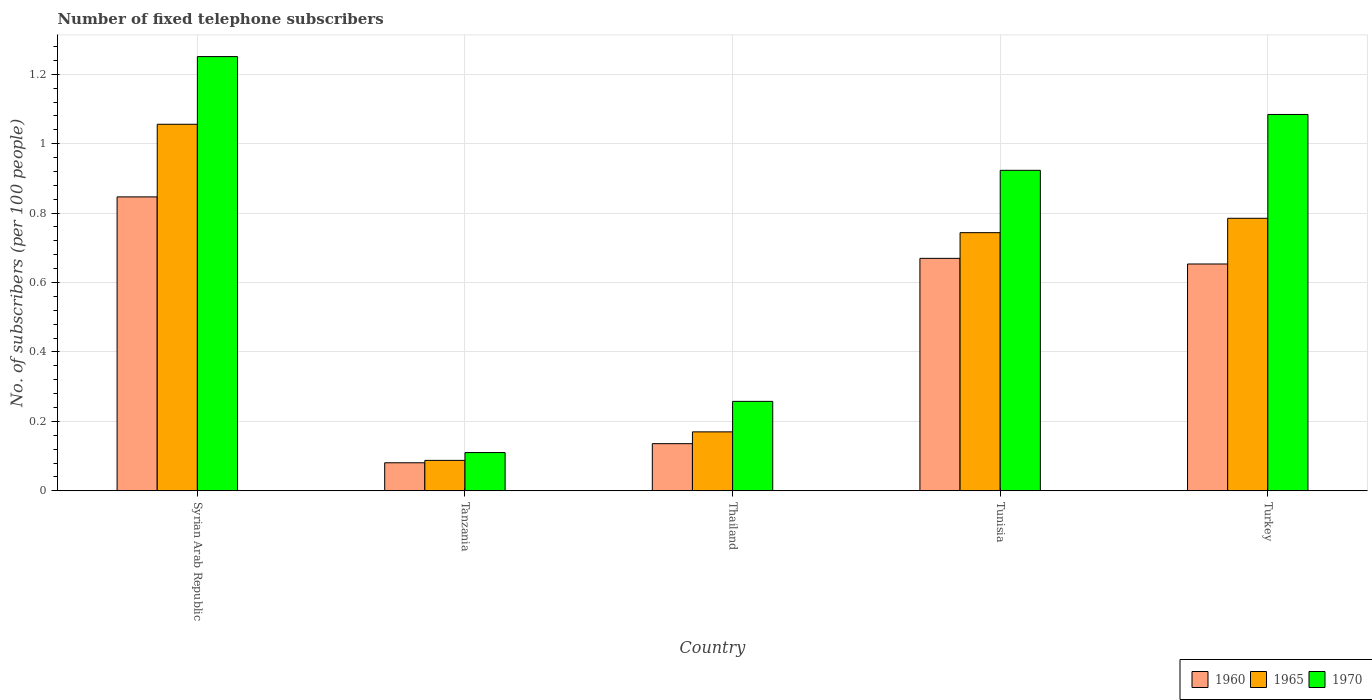How many groups of bars are there?
Your answer should be very brief. 5. Are the number of bars per tick equal to the number of legend labels?
Make the answer very short. Yes. What is the label of the 1st group of bars from the left?
Your response must be concise. Syrian Arab Republic. In how many cases, is the number of bars for a given country not equal to the number of legend labels?
Keep it short and to the point. 0. What is the number of fixed telephone subscribers in 1970 in Turkey?
Ensure brevity in your answer.  1.08. Across all countries, what is the maximum number of fixed telephone subscribers in 1960?
Provide a succinct answer. 0.85. Across all countries, what is the minimum number of fixed telephone subscribers in 1960?
Offer a very short reply. 0.08. In which country was the number of fixed telephone subscribers in 1965 maximum?
Provide a succinct answer. Syrian Arab Republic. In which country was the number of fixed telephone subscribers in 1960 minimum?
Your response must be concise. Tanzania. What is the total number of fixed telephone subscribers in 1965 in the graph?
Offer a very short reply. 2.84. What is the difference between the number of fixed telephone subscribers in 1970 in Syrian Arab Republic and that in Tunisia?
Your answer should be compact. 0.33. What is the difference between the number of fixed telephone subscribers in 1960 in Turkey and the number of fixed telephone subscribers in 1970 in Syrian Arab Republic?
Offer a very short reply. -0.6. What is the average number of fixed telephone subscribers in 1965 per country?
Provide a succinct answer. 0.57. What is the difference between the number of fixed telephone subscribers of/in 1970 and number of fixed telephone subscribers of/in 1960 in Thailand?
Give a very brief answer. 0.12. What is the ratio of the number of fixed telephone subscribers in 1965 in Syrian Arab Republic to that in Tunisia?
Keep it short and to the point. 1.42. Is the number of fixed telephone subscribers in 1960 in Syrian Arab Republic less than that in Thailand?
Offer a terse response. No. What is the difference between the highest and the second highest number of fixed telephone subscribers in 1970?
Offer a terse response. -0.33. What is the difference between the highest and the lowest number of fixed telephone subscribers in 1960?
Your response must be concise. 0.77. Is the sum of the number of fixed telephone subscribers in 1965 in Tanzania and Thailand greater than the maximum number of fixed telephone subscribers in 1970 across all countries?
Keep it short and to the point. No. What does the 1st bar from the left in Thailand represents?
Ensure brevity in your answer.  1960. What does the 2nd bar from the right in Tunisia represents?
Provide a short and direct response. 1965. Is it the case that in every country, the sum of the number of fixed telephone subscribers in 1960 and number of fixed telephone subscribers in 1965 is greater than the number of fixed telephone subscribers in 1970?
Keep it short and to the point. Yes. Are all the bars in the graph horizontal?
Your answer should be very brief. No. How many countries are there in the graph?
Offer a very short reply. 5. What is the difference between two consecutive major ticks on the Y-axis?
Ensure brevity in your answer.  0.2. Are the values on the major ticks of Y-axis written in scientific E-notation?
Ensure brevity in your answer.  No. Does the graph contain grids?
Give a very brief answer. Yes. Where does the legend appear in the graph?
Give a very brief answer. Bottom right. How many legend labels are there?
Your answer should be compact. 3. What is the title of the graph?
Ensure brevity in your answer.  Number of fixed telephone subscribers. What is the label or title of the X-axis?
Offer a very short reply. Country. What is the label or title of the Y-axis?
Your response must be concise. No. of subscribers (per 100 people). What is the No. of subscribers (per 100 people) of 1960 in Syrian Arab Republic?
Ensure brevity in your answer.  0.85. What is the No. of subscribers (per 100 people) of 1965 in Syrian Arab Republic?
Provide a short and direct response. 1.06. What is the No. of subscribers (per 100 people) in 1970 in Syrian Arab Republic?
Your response must be concise. 1.25. What is the No. of subscribers (per 100 people) of 1960 in Tanzania?
Your answer should be very brief. 0.08. What is the No. of subscribers (per 100 people) in 1965 in Tanzania?
Give a very brief answer. 0.09. What is the No. of subscribers (per 100 people) in 1970 in Tanzania?
Ensure brevity in your answer.  0.11. What is the No. of subscribers (per 100 people) of 1960 in Thailand?
Make the answer very short. 0.14. What is the No. of subscribers (per 100 people) of 1965 in Thailand?
Your answer should be compact. 0.17. What is the No. of subscribers (per 100 people) of 1970 in Thailand?
Give a very brief answer. 0.26. What is the No. of subscribers (per 100 people) in 1960 in Tunisia?
Ensure brevity in your answer.  0.67. What is the No. of subscribers (per 100 people) in 1965 in Tunisia?
Ensure brevity in your answer.  0.74. What is the No. of subscribers (per 100 people) of 1970 in Tunisia?
Ensure brevity in your answer.  0.92. What is the No. of subscribers (per 100 people) in 1960 in Turkey?
Provide a succinct answer. 0.65. What is the No. of subscribers (per 100 people) in 1965 in Turkey?
Your answer should be very brief. 0.79. What is the No. of subscribers (per 100 people) of 1970 in Turkey?
Provide a short and direct response. 1.08. Across all countries, what is the maximum No. of subscribers (per 100 people) of 1960?
Ensure brevity in your answer.  0.85. Across all countries, what is the maximum No. of subscribers (per 100 people) in 1965?
Keep it short and to the point. 1.06. Across all countries, what is the maximum No. of subscribers (per 100 people) of 1970?
Ensure brevity in your answer.  1.25. Across all countries, what is the minimum No. of subscribers (per 100 people) in 1960?
Provide a succinct answer. 0.08. Across all countries, what is the minimum No. of subscribers (per 100 people) of 1965?
Offer a terse response. 0.09. Across all countries, what is the minimum No. of subscribers (per 100 people) of 1970?
Offer a very short reply. 0.11. What is the total No. of subscribers (per 100 people) of 1960 in the graph?
Offer a terse response. 2.39. What is the total No. of subscribers (per 100 people) of 1965 in the graph?
Offer a very short reply. 2.84. What is the total No. of subscribers (per 100 people) in 1970 in the graph?
Offer a very short reply. 3.63. What is the difference between the No. of subscribers (per 100 people) of 1960 in Syrian Arab Republic and that in Tanzania?
Provide a succinct answer. 0.77. What is the difference between the No. of subscribers (per 100 people) in 1965 in Syrian Arab Republic and that in Tanzania?
Keep it short and to the point. 0.97. What is the difference between the No. of subscribers (per 100 people) of 1970 in Syrian Arab Republic and that in Tanzania?
Give a very brief answer. 1.14. What is the difference between the No. of subscribers (per 100 people) of 1960 in Syrian Arab Republic and that in Thailand?
Your answer should be very brief. 0.71. What is the difference between the No. of subscribers (per 100 people) in 1965 in Syrian Arab Republic and that in Thailand?
Your answer should be compact. 0.89. What is the difference between the No. of subscribers (per 100 people) of 1970 in Syrian Arab Republic and that in Thailand?
Provide a short and direct response. 0.99. What is the difference between the No. of subscribers (per 100 people) in 1960 in Syrian Arab Republic and that in Tunisia?
Make the answer very short. 0.18. What is the difference between the No. of subscribers (per 100 people) in 1965 in Syrian Arab Republic and that in Tunisia?
Ensure brevity in your answer.  0.31. What is the difference between the No. of subscribers (per 100 people) in 1970 in Syrian Arab Republic and that in Tunisia?
Your answer should be compact. 0.33. What is the difference between the No. of subscribers (per 100 people) of 1960 in Syrian Arab Republic and that in Turkey?
Make the answer very short. 0.19. What is the difference between the No. of subscribers (per 100 people) of 1965 in Syrian Arab Republic and that in Turkey?
Make the answer very short. 0.27. What is the difference between the No. of subscribers (per 100 people) of 1960 in Tanzania and that in Thailand?
Offer a very short reply. -0.06. What is the difference between the No. of subscribers (per 100 people) in 1965 in Tanzania and that in Thailand?
Provide a succinct answer. -0.08. What is the difference between the No. of subscribers (per 100 people) in 1970 in Tanzania and that in Thailand?
Make the answer very short. -0.15. What is the difference between the No. of subscribers (per 100 people) in 1960 in Tanzania and that in Tunisia?
Your answer should be compact. -0.59. What is the difference between the No. of subscribers (per 100 people) of 1965 in Tanzania and that in Tunisia?
Provide a short and direct response. -0.66. What is the difference between the No. of subscribers (per 100 people) in 1970 in Tanzania and that in Tunisia?
Offer a very short reply. -0.81. What is the difference between the No. of subscribers (per 100 people) of 1960 in Tanzania and that in Turkey?
Keep it short and to the point. -0.57. What is the difference between the No. of subscribers (per 100 people) of 1965 in Tanzania and that in Turkey?
Ensure brevity in your answer.  -0.7. What is the difference between the No. of subscribers (per 100 people) of 1970 in Tanzania and that in Turkey?
Give a very brief answer. -0.97. What is the difference between the No. of subscribers (per 100 people) of 1960 in Thailand and that in Tunisia?
Your answer should be very brief. -0.53. What is the difference between the No. of subscribers (per 100 people) in 1965 in Thailand and that in Tunisia?
Provide a short and direct response. -0.57. What is the difference between the No. of subscribers (per 100 people) of 1970 in Thailand and that in Tunisia?
Provide a short and direct response. -0.67. What is the difference between the No. of subscribers (per 100 people) of 1960 in Thailand and that in Turkey?
Give a very brief answer. -0.52. What is the difference between the No. of subscribers (per 100 people) in 1965 in Thailand and that in Turkey?
Provide a short and direct response. -0.62. What is the difference between the No. of subscribers (per 100 people) in 1970 in Thailand and that in Turkey?
Give a very brief answer. -0.83. What is the difference between the No. of subscribers (per 100 people) of 1960 in Tunisia and that in Turkey?
Offer a very short reply. 0.02. What is the difference between the No. of subscribers (per 100 people) of 1965 in Tunisia and that in Turkey?
Offer a terse response. -0.04. What is the difference between the No. of subscribers (per 100 people) of 1970 in Tunisia and that in Turkey?
Keep it short and to the point. -0.16. What is the difference between the No. of subscribers (per 100 people) of 1960 in Syrian Arab Republic and the No. of subscribers (per 100 people) of 1965 in Tanzania?
Offer a very short reply. 0.76. What is the difference between the No. of subscribers (per 100 people) of 1960 in Syrian Arab Republic and the No. of subscribers (per 100 people) of 1970 in Tanzania?
Ensure brevity in your answer.  0.74. What is the difference between the No. of subscribers (per 100 people) in 1965 in Syrian Arab Republic and the No. of subscribers (per 100 people) in 1970 in Tanzania?
Ensure brevity in your answer.  0.95. What is the difference between the No. of subscribers (per 100 people) of 1960 in Syrian Arab Republic and the No. of subscribers (per 100 people) of 1965 in Thailand?
Ensure brevity in your answer.  0.68. What is the difference between the No. of subscribers (per 100 people) of 1960 in Syrian Arab Republic and the No. of subscribers (per 100 people) of 1970 in Thailand?
Keep it short and to the point. 0.59. What is the difference between the No. of subscribers (per 100 people) in 1965 in Syrian Arab Republic and the No. of subscribers (per 100 people) in 1970 in Thailand?
Your answer should be very brief. 0.8. What is the difference between the No. of subscribers (per 100 people) in 1960 in Syrian Arab Republic and the No. of subscribers (per 100 people) in 1965 in Tunisia?
Give a very brief answer. 0.1. What is the difference between the No. of subscribers (per 100 people) of 1960 in Syrian Arab Republic and the No. of subscribers (per 100 people) of 1970 in Tunisia?
Keep it short and to the point. -0.08. What is the difference between the No. of subscribers (per 100 people) in 1965 in Syrian Arab Republic and the No. of subscribers (per 100 people) in 1970 in Tunisia?
Make the answer very short. 0.13. What is the difference between the No. of subscribers (per 100 people) in 1960 in Syrian Arab Republic and the No. of subscribers (per 100 people) in 1965 in Turkey?
Offer a terse response. 0.06. What is the difference between the No. of subscribers (per 100 people) of 1960 in Syrian Arab Republic and the No. of subscribers (per 100 people) of 1970 in Turkey?
Offer a terse response. -0.24. What is the difference between the No. of subscribers (per 100 people) in 1965 in Syrian Arab Republic and the No. of subscribers (per 100 people) in 1970 in Turkey?
Make the answer very short. -0.03. What is the difference between the No. of subscribers (per 100 people) in 1960 in Tanzania and the No. of subscribers (per 100 people) in 1965 in Thailand?
Make the answer very short. -0.09. What is the difference between the No. of subscribers (per 100 people) of 1960 in Tanzania and the No. of subscribers (per 100 people) of 1970 in Thailand?
Give a very brief answer. -0.18. What is the difference between the No. of subscribers (per 100 people) in 1965 in Tanzania and the No. of subscribers (per 100 people) in 1970 in Thailand?
Your response must be concise. -0.17. What is the difference between the No. of subscribers (per 100 people) of 1960 in Tanzania and the No. of subscribers (per 100 people) of 1965 in Tunisia?
Provide a succinct answer. -0.66. What is the difference between the No. of subscribers (per 100 people) in 1960 in Tanzania and the No. of subscribers (per 100 people) in 1970 in Tunisia?
Provide a succinct answer. -0.84. What is the difference between the No. of subscribers (per 100 people) in 1965 in Tanzania and the No. of subscribers (per 100 people) in 1970 in Tunisia?
Ensure brevity in your answer.  -0.84. What is the difference between the No. of subscribers (per 100 people) of 1960 in Tanzania and the No. of subscribers (per 100 people) of 1965 in Turkey?
Your answer should be compact. -0.7. What is the difference between the No. of subscribers (per 100 people) in 1960 in Tanzania and the No. of subscribers (per 100 people) in 1970 in Turkey?
Offer a terse response. -1. What is the difference between the No. of subscribers (per 100 people) of 1965 in Tanzania and the No. of subscribers (per 100 people) of 1970 in Turkey?
Your answer should be compact. -1. What is the difference between the No. of subscribers (per 100 people) of 1960 in Thailand and the No. of subscribers (per 100 people) of 1965 in Tunisia?
Provide a succinct answer. -0.61. What is the difference between the No. of subscribers (per 100 people) in 1960 in Thailand and the No. of subscribers (per 100 people) in 1970 in Tunisia?
Give a very brief answer. -0.79. What is the difference between the No. of subscribers (per 100 people) of 1965 in Thailand and the No. of subscribers (per 100 people) of 1970 in Tunisia?
Offer a very short reply. -0.75. What is the difference between the No. of subscribers (per 100 people) of 1960 in Thailand and the No. of subscribers (per 100 people) of 1965 in Turkey?
Give a very brief answer. -0.65. What is the difference between the No. of subscribers (per 100 people) in 1960 in Thailand and the No. of subscribers (per 100 people) in 1970 in Turkey?
Offer a very short reply. -0.95. What is the difference between the No. of subscribers (per 100 people) of 1965 in Thailand and the No. of subscribers (per 100 people) of 1970 in Turkey?
Offer a very short reply. -0.91. What is the difference between the No. of subscribers (per 100 people) of 1960 in Tunisia and the No. of subscribers (per 100 people) of 1965 in Turkey?
Your response must be concise. -0.12. What is the difference between the No. of subscribers (per 100 people) of 1960 in Tunisia and the No. of subscribers (per 100 people) of 1970 in Turkey?
Keep it short and to the point. -0.41. What is the difference between the No. of subscribers (per 100 people) of 1965 in Tunisia and the No. of subscribers (per 100 people) of 1970 in Turkey?
Your answer should be very brief. -0.34. What is the average No. of subscribers (per 100 people) in 1960 per country?
Provide a short and direct response. 0.48. What is the average No. of subscribers (per 100 people) of 1965 per country?
Your answer should be compact. 0.57. What is the average No. of subscribers (per 100 people) of 1970 per country?
Offer a terse response. 0.73. What is the difference between the No. of subscribers (per 100 people) in 1960 and No. of subscribers (per 100 people) in 1965 in Syrian Arab Republic?
Offer a terse response. -0.21. What is the difference between the No. of subscribers (per 100 people) of 1960 and No. of subscribers (per 100 people) of 1970 in Syrian Arab Republic?
Your response must be concise. -0.4. What is the difference between the No. of subscribers (per 100 people) in 1965 and No. of subscribers (per 100 people) in 1970 in Syrian Arab Republic?
Provide a succinct answer. -0.2. What is the difference between the No. of subscribers (per 100 people) in 1960 and No. of subscribers (per 100 people) in 1965 in Tanzania?
Make the answer very short. -0.01. What is the difference between the No. of subscribers (per 100 people) in 1960 and No. of subscribers (per 100 people) in 1970 in Tanzania?
Provide a short and direct response. -0.03. What is the difference between the No. of subscribers (per 100 people) in 1965 and No. of subscribers (per 100 people) in 1970 in Tanzania?
Provide a short and direct response. -0.02. What is the difference between the No. of subscribers (per 100 people) in 1960 and No. of subscribers (per 100 people) in 1965 in Thailand?
Offer a terse response. -0.03. What is the difference between the No. of subscribers (per 100 people) of 1960 and No. of subscribers (per 100 people) of 1970 in Thailand?
Offer a very short reply. -0.12. What is the difference between the No. of subscribers (per 100 people) in 1965 and No. of subscribers (per 100 people) in 1970 in Thailand?
Provide a short and direct response. -0.09. What is the difference between the No. of subscribers (per 100 people) in 1960 and No. of subscribers (per 100 people) in 1965 in Tunisia?
Your response must be concise. -0.07. What is the difference between the No. of subscribers (per 100 people) of 1960 and No. of subscribers (per 100 people) of 1970 in Tunisia?
Your answer should be compact. -0.25. What is the difference between the No. of subscribers (per 100 people) in 1965 and No. of subscribers (per 100 people) in 1970 in Tunisia?
Provide a succinct answer. -0.18. What is the difference between the No. of subscribers (per 100 people) in 1960 and No. of subscribers (per 100 people) in 1965 in Turkey?
Your answer should be very brief. -0.13. What is the difference between the No. of subscribers (per 100 people) in 1960 and No. of subscribers (per 100 people) in 1970 in Turkey?
Make the answer very short. -0.43. What is the difference between the No. of subscribers (per 100 people) in 1965 and No. of subscribers (per 100 people) in 1970 in Turkey?
Provide a succinct answer. -0.3. What is the ratio of the No. of subscribers (per 100 people) of 1960 in Syrian Arab Republic to that in Tanzania?
Offer a terse response. 10.49. What is the ratio of the No. of subscribers (per 100 people) in 1965 in Syrian Arab Republic to that in Tanzania?
Make the answer very short. 12.06. What is the ratio of the No. of subscribers (per 100 people) of 1970 in Syrian Arab Republic to that in Tanzania?
Offer a very short reply. 11.36. What is the ratio of the No. of subscribers (per 100 people) in 1960 in Syrian Arab Republic to that in Thailand?
Make the answer very short. 6.24. What is the ratio of the No. of subscribers (per 100 people) of 1965 in Syrian Arab Republic to that in Thailand?
Your response must be concise. 6.22. What is the ratio of the No. of subscribers (per 100 people) of 1970 in Syrian Arab Republic to that in Thailand?
Make the answer very short. 4.86. What is the ratio of the No. of subscribers (per 100 people) in 1960 in Syrian Arab Republic to that in Tunisia?
Ensure brevity in your answer.  1.26. What is the ratio of the No. of subscribers (per 100 people) of 1965 in Syrian Arab Republic to that in Tunisia?
Keep it short and to the point. 1.42. What is the ratio of the No. of subscribers (per 100 people) of 1970 in Syrian Arab Republic to that in Tunisia?
Give a very brief answer. 1.35. What is the ratio of the No. of subscribers (per 100 people) in 1960 in Syrian Arab Republic to that in Turkey?
Your response must be concise. 1.3. What is the ratio of the No. of subscribers (per 100 people) of 1965 in Syrian Arab Republic to that in Turkey?
Make the answer very short. 1.34. What is the ratio of the No. of subscribers (per 100 people) in 1970 in Syrian Arab Republic to that in Turkey?
Keep it short and to the point. 1.15. What is the ratio of the No. of subscribers (per 100 people) of 1960 in Tanzania to that in Thailand?
Provide a short and direct response. 0.59. What is the ratio of the No. of subscribers (per 100 people) of 1965 in Tanzania to that in Thailand?
Provide a succinct answer. 0.52. What is the ratio of the No. of subscribers (per 100 people) of 1970 in Tanzania to that in Thailand?
Make the answer very short. 0.43. What is the ratio of the No. of subscribers (per 100 people) of 1960 in Tanzania to that in Tunisia?
Your answer should be very brief. 0.12. What is the ratio of the No. of subscribers (per 100 people) of 1965 in Tanzania to that in Tunisia?
Ensure brevity in your answer.  0.12. What is the ratio of the No. of subscribers (per 100 people) of 1970 in Tanzania to that in Tunisia?
Ensure brevity in your answer.  0.12. What is the ratio of the No. of subscribers (per 100 people) in 1960 in Tanzania to that in Turkey?
Provide a succinct answer. 0.12. What is the ratio of the No. of subscribers (per 100 people) in 1965 in Tanzania to that in Turkey?
Offer a terse response. 0.11. What is the ratio of the No. of subscribers (per 100 people) in 1970 in Tanzania to that in Turkey?
Your answer should be very brief. 0.1. What is the ratio of the No. of subscribers (per 100 people) of 1960 in Thailand to that in Tunisia?
Keep it short and to the point. 0.2. What is the ratio of the No. of subscribers (per 100 people) of 1965 in Thailand to that in Tunisia?
Offer a very short reply. 0.23. What is the ratio of the No. of subscribers (per 100 people) in 1970 in Thailand to that in Tunisia?
Provide a short and direct response. 0.28. What is the ratio of the No. of subscribers (per 100 people) of 1960 in Thailand to that in Turkey?
Keep it short and to the point. 0.21. What is the ratio of the No. of subscribers (per 100 people) in 1965 in Thailand to that in Turkey?
Your answer should be very brief. 0.22. What is the ratio of the No. of subscribers (per 100 people) of 1970 in Thailand to that in Turkey?
Offer a terse response. 0.24. What is the ratio of the No. of subscribers (per 100 people) in 1960 in Tunisia to that in Turkey?
Your answer should be compact. 1.02. What is the ratio of the No. of subscribers (per 100 people) in 1965 in Tunisia to that in Turkey?
Offer a very short reply. 0.95. What is the ratio of the No. of subscribers (per 100 people) in 1970 in Tunisia to that in Turkey?
Offer a terse response. 0.85. What is the difference between the highest and the second highest No. of subscribers (per 100 people) of 1960?
Offer a terse response. 0.18. What is the difference between the highest and the second highest No. of subscribers (per 100 people) of 1965?
Provide a short and direct response. 0.27. What is the difference between the highest and the second highest No. of subscribers (per 100 people) of 1970?
Your answer should be very brief. 0.17. What is the difference between the highest and the lowest No. of subscribers (per 100 people) in 1960?
Provide a succinct answer. 0.77. What is the difference between the highest and the lowest No. of subscribers (per 100 people) in 1965?
Provide a succinct answer. 0.97. What is the difference between the highest and the lowest No. of subscribers (per 100 people) of 1970?
Offer a terse response. 1.14. 